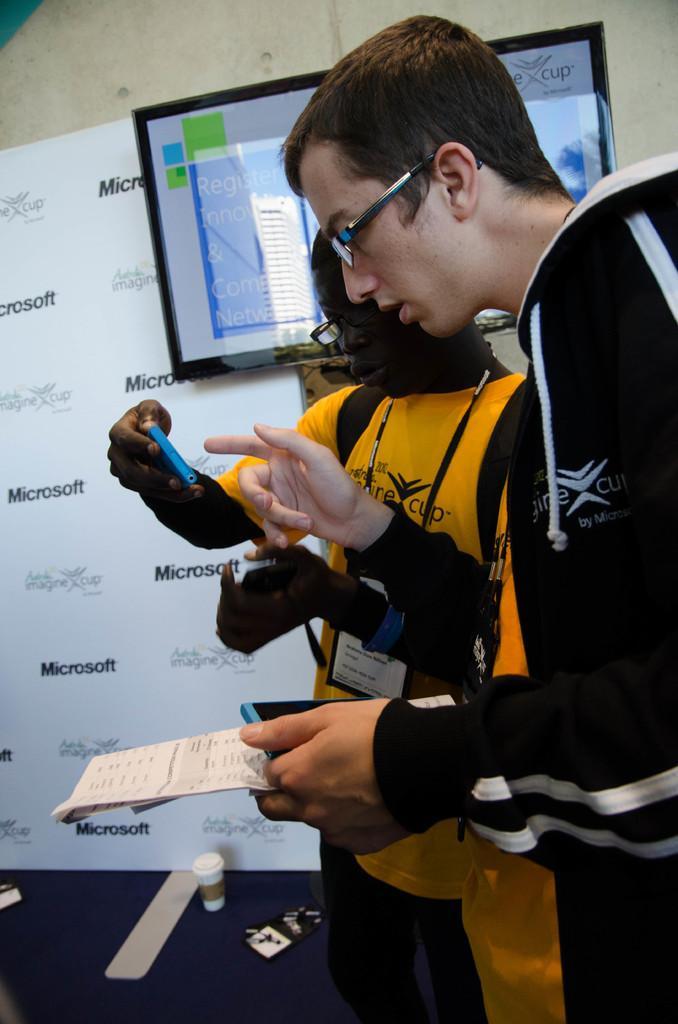Please provide a concise description of this image. There are two people standing and wore glasses and holding mobiles. Background we can see banner,wall and screen. We can see glass on the floor. 